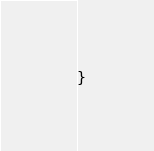<code> <loc_0><loc_0><loc_500><loc_500><_Java_>
}
</code> 